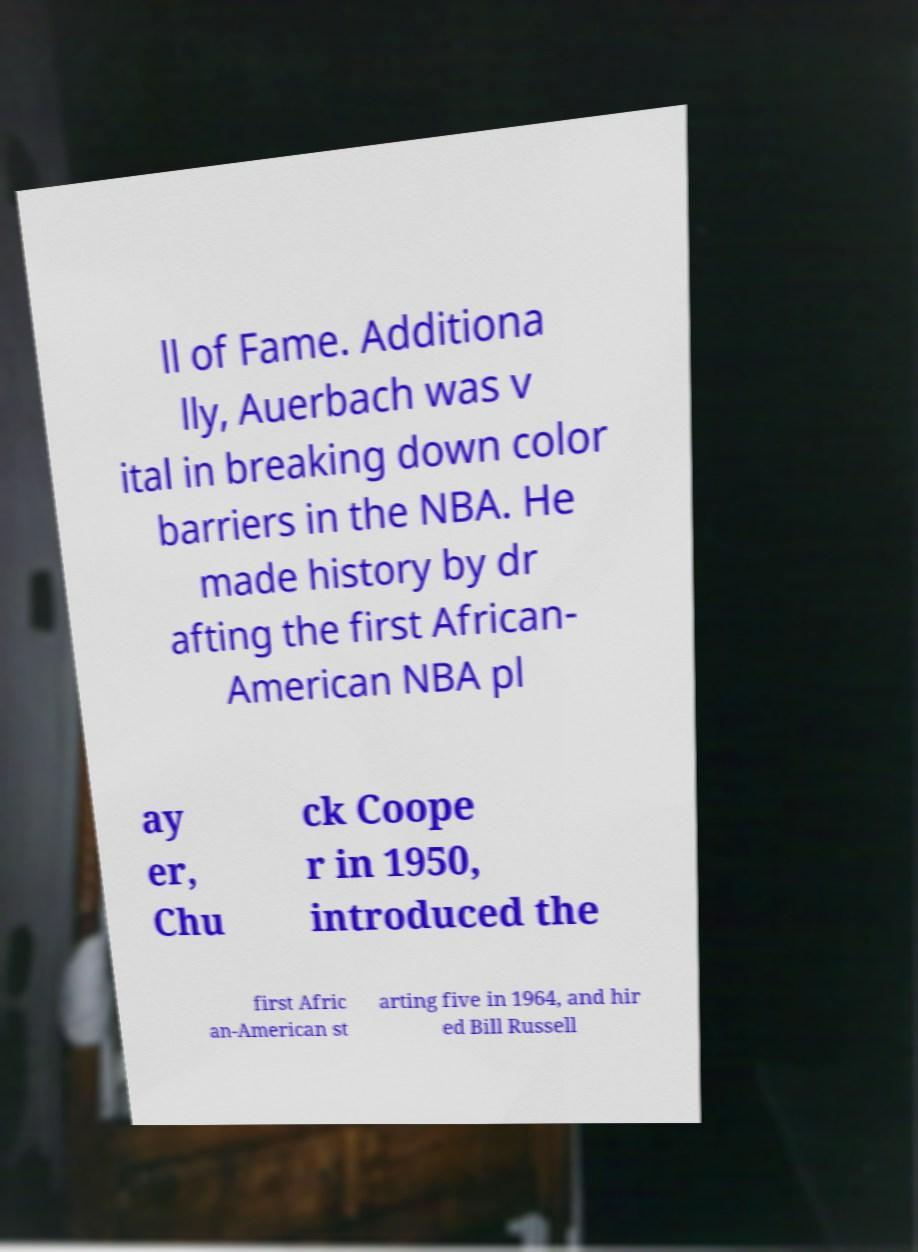There's text embedded in this image that I need extracted. Can you transcribe it verbatim? ll of Fame. Additiona lly, Auerbach was v ital in breaking down color barriers in the NBA. He made history by dr afting the first African- American NBA pl ay er, Chu ck Coope r in 1950, introduced the first Afric an-American st arting five in 1964, and hir ed Bill Russell 